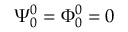<formula> <loc_0><loc_0><loc_500><loc_500>\Psi _ { 0 } ^ { 0 } = \Phi _ { 0 } ^ { 0 } = 0</formula> 